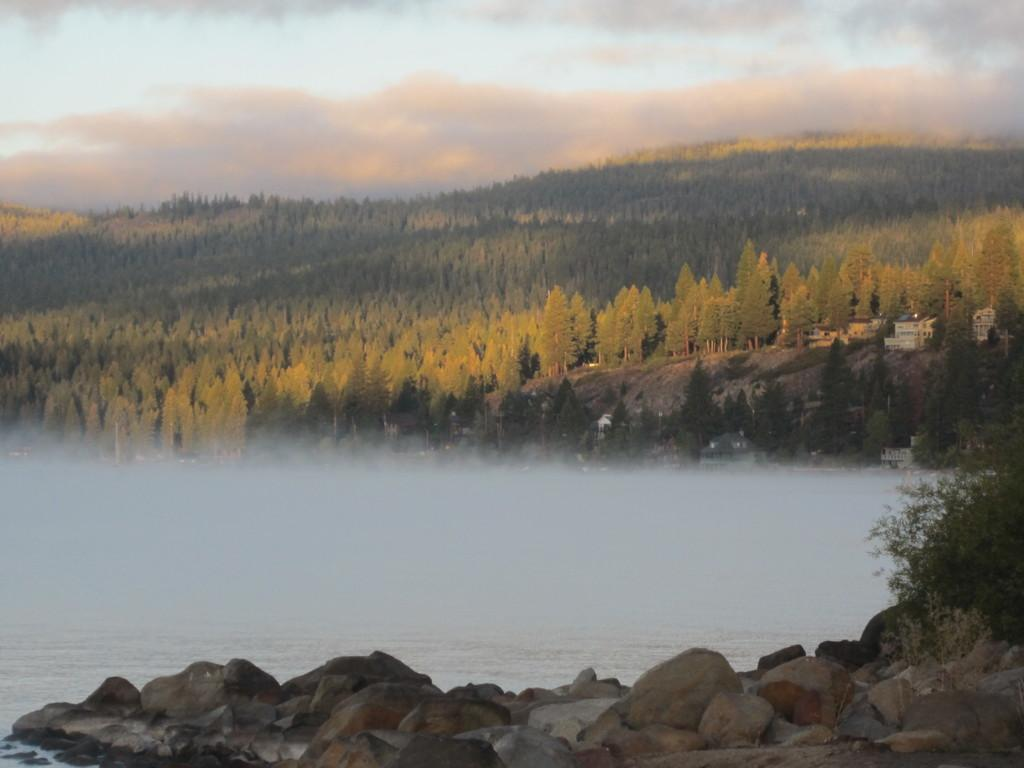What type of natural elements can be seen in the image? There are rocks and water visible in the image. What type of vegetation is in the background of the image? There are trees in the background of the image. What is the weight of the grandmother's sock in the image? There is no grandmother or sock present in the image. 